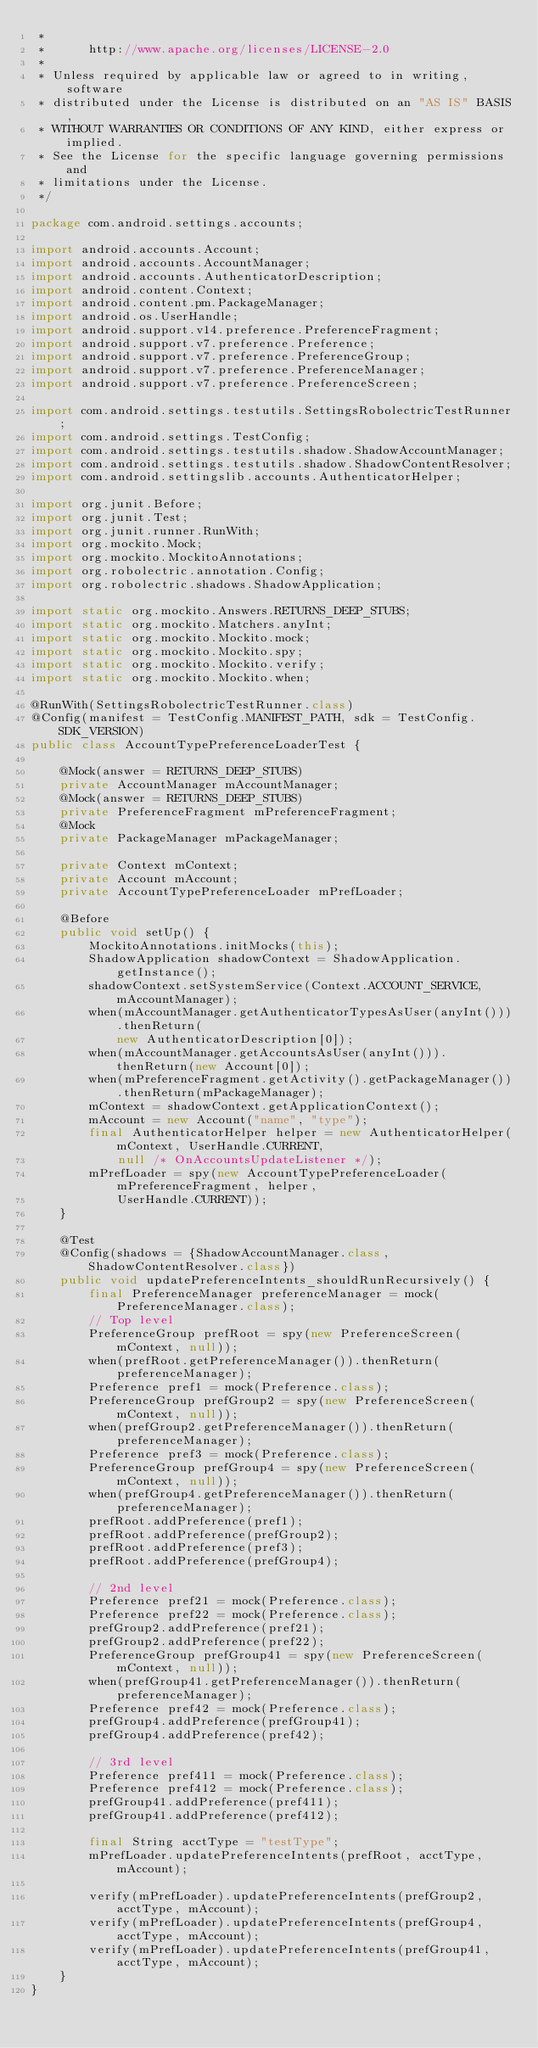<code> <loc_0><loc_0><loc_500><loc_500><_Java_> *
 *      http://www.apache.org/licenses/LICENSE-2.0
 *
 * Unless required by applicable law or agreed to in writing, software
 * distributed under the License is distributed on an "AS IS" BASIS,
 * WITHOUT WARRANTIES OR CONDITIONS OF ANY KIND, either express or implied.
 * See the License for the specific language governing permissions and
 * limitations under the License.
 */

package com.android.settings.accounts;

import android.accounts.Account;
import android.accounts.AccountManager;
import android.accounts.AuthenticatorDescription;
import android.content.Context;
import android.content.pm.PackageManager;
import android.os.UserHandle;
import android.support.v14.preference.PreferenceFragment;
import android.support.v7.preference.Preference;
import android.support.v7.preference.PreferenceGroup;
import android.support.v7.preference.PreferenceManager;
import android.support.v7.preference.PreferenceScreen;

import com.android.settings.testutils.SettingsRobolectricTestRunner;
import com.android.settings.TestConfig;
import com.android.settings.testutils.shadow.ShadowAccountManager;
import com.android.settings.testutils.shadow.ShadowContentResolver;
import com.android.settingslib.accounts.AuthenticatorHelper;

import org.junit.Before;
import org.junit.Test;
import org.junit.runner.RunWith;
import org.mockito.Mock;
import org.mockito.MockitoAnnotations;
import org.robolectric.annotation.Config;
import org.robolectric.shadows.ShadowApplication;

import static org.mockito.Answers.RETURNS_DEEP_STUBS;
import static org.mockito.Matchers.anyInt;
import static org.mockito.Mockito.mock;
import static org.mockito.Mockito.spy;
import static org.mockito.Mockito.verify;
import static org.mockito.Mockito.when;

@RunWith(SettingsRobolectricTestRunner.class)
@Config(manifest = TestConfig.MANIFEST_PATH, sdk = TestConfig.SDK_VERSION)
public class AccountTypePreferenceLoaderTest {

    @Mock(answer = RETURNS_DEEP_STUBS)
    private AccountManager mAccountManager;
    @Mock(answer = RETURNS_DEEP_STUBS)
    private PreferenceFragment mPreferenceFragment;
    @Mock
    private PackageManager mPackageManager;

    private Context mContext;
    private Account mAccount;
    private AccountTypePreferenceLoader mPrefLoader;

    @Before
    public void setUp() {
        MockitoAnnotations.initMocks(this);
        ShadowApplication shadowContext = ShadowApplication.getInstance();
        shadowContext.setSystemService(Context.ACCOUNT_SERVICE, mAccountManager);
        when(mAccountManager.getAuthenticatorTypesAsUser(anyInt())).thenReturn(
            new AuthenticatorDescription[0]);
        when(mAccountManager.getAccountsAsUser(anyInt())).thenReturn(new Account[0]);
        when(mPreferenceFragment.getActivity().getPackageManager()).thenReturn(mPackageManager);
        mContext = shadowContext.getApplicationContext();
        mAccount = new Account("name", "type");
        final AuthenticatorHelper helper = new AuthenticatorHelper(mContext, UserHandle.CURRENT,
            null /* OnAccountsUpdateListener */);
        mPrefLoader = spy(new AccountTypePreferenceLoader(mPreferenceFragment, helper,
            UserHandle.CURRENT));
    }

    @Test
    @Config(shadows = {ShadowAccountManager.class, ShadowContentResolver.class})
    public void updatePreferenceIntents_shouldRunRecursively() {
        final PreferenceManager preferenceManager = mock(PreferenceManager.class);
        // Top level
        PreferenceGroup prefRoot = spy(new PreferenceScreen(mContext, null));
        when(prefRoot.getPreferenceManager()).thenReturn(preferenceManager);
        Preference pref1 = mock(Preference.class);
        PreferenceGroup prefGroup2 = spy(new PreferenceScreen(mContext, null));
        when(prefGroup2.getPreferenceManager()).thenReturn(preferenceManager);
        Preference pref3 = mock(Preference.class);
        PreferenceGroup prefGroup4 = spy(new PreferenceScreen(mContext, null));
        when(prefGroup4.getPreferenceManager()).thenReturn(preferenceManager);
        prefRoot.addPreference(pref1);
        prefRoot.addPreference(prefGroup2);
        prefRoot.addPreference(pref3);
        prefRoot.addPreference(prefGroup4);

        // 2nd level
        Preference pref21 = mock(Preference.class);
        Preference pref22 = mock(Preference.class);
        prefGroup2.addPreference(pref21);
        prefGroup2.addPreference(pref22);
        PreferenceGroup prefGroup41 = spy(new PreferenceScreen(mContext, null));
        when(prefGroup41.getPreferenceManager()).thenReturn(preferenceManager);
        Preference pref42 = mock(Preference.class);
        prefGroup4.addPreference(prefGroup41);
        prefGroup4.addPreference(pref42);

        // 3rd level
        Preference pref411 = mock(Preference.class);
        Preference pref412 = mock(Preference.class);
        prefGroup41.addPreference(pref411);
        prefGroup41.addPreference(pref412);

        final String acctType = "testType";
        mPrefLoader.updatePreferenceIntents(prefRoot, acctType, mAccount);

        verify(mPrefLoader).updatePreferenceIntents(prefGroup2, acctType, mAccount);
        verify(mPrefLoader).updatePreferenceIntents(prefGroup4, acctType, mAccount);
        verify(mPrefLoader).updatePreferenceIntents(prefGroup41, acctType, mAccount);
    }
}
</code> 